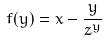Convert formula to latex. <formula><loc_0><loc_0><loc_500><loc_500>f ( y ) = x - \frac { y } { z ^ { y } }</formula> 